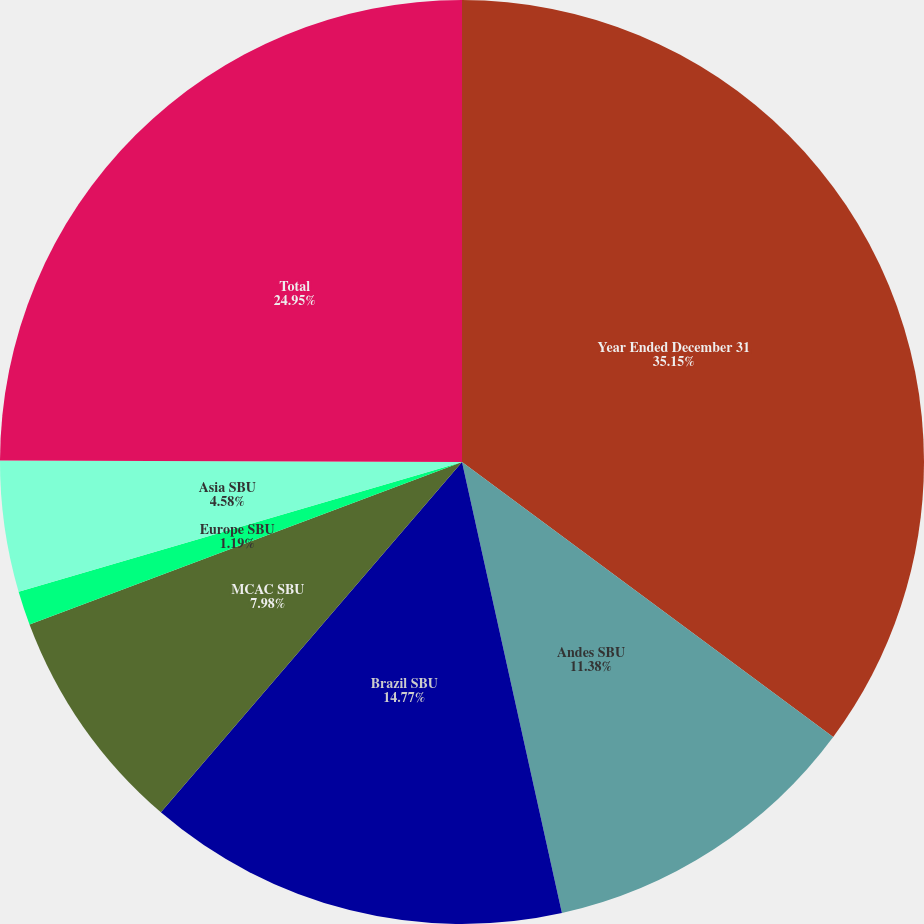<chart> <loc_0><loc_0><loc_500><loc_500><pie_chart><fcel>Year Ended December 31<fcel>Andes SBU<fcel>Brazil SBU<fcel>MCAC SBU<fcel>Europe SBU<fcel>Asia SBU<fcel>Total<nl><fcel>35.15%<fcel>11.38%<fcel>14.77%<fcel>7.98%<fcel>1.19%<fcel>4.58%<fcel>24.95%<nl></chart> 